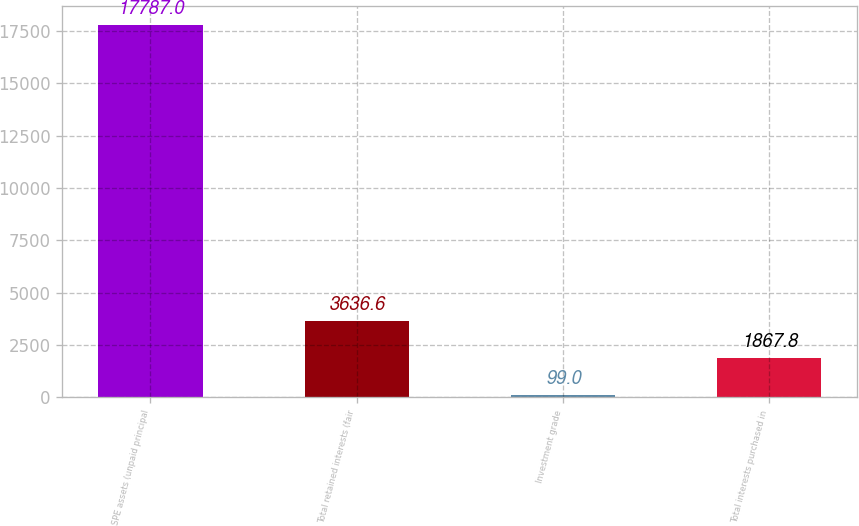<chart> <loc_0><loc_0><loc_500><loc_500><bar_chart><fcel>SPE assets (unpaid principal<fcel>Total retained interests (fair<fcel>Investment grade<fcel>Total interests purchased in<nl><fcel>17787<fcel>3636.6<fcel>99<fcel>1867.8<nl></chart> 